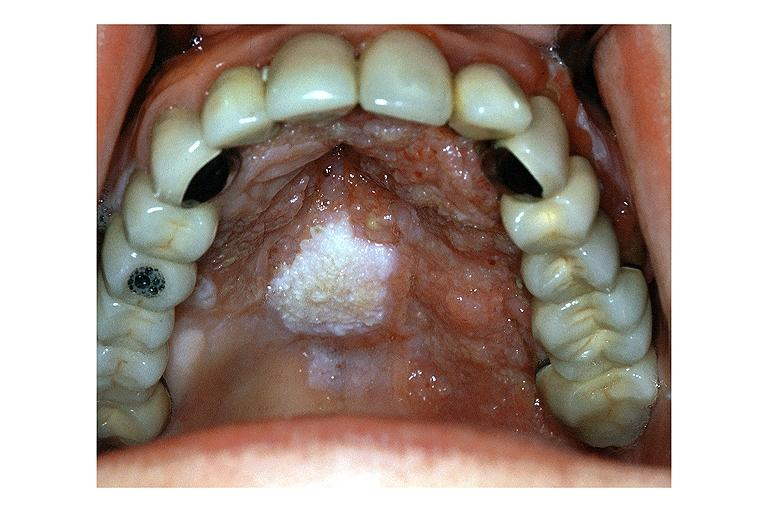s oral present?
Answer the question using a single word or phrase. Yes 